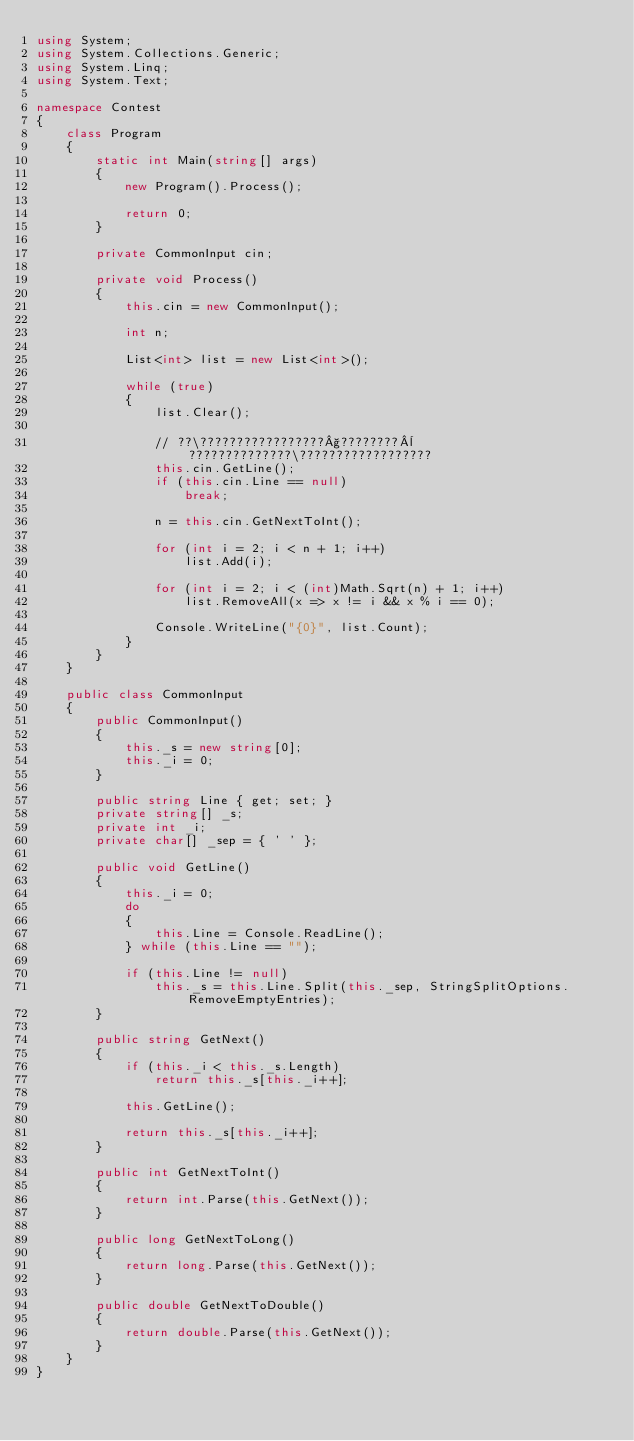Convert code to text. <code><loc_0><loc_0><loc_500><loc_500><_C#_>using System;
using System.Collections.Generic;
using System.Linq;
using System.Text;

namespace Contest
{
    class Program
    {
        static int Main(string[] args)
        {
            new Program().Process();

            return 0;
        }

        private CommonInput cin;

        private void Process()
        {
            this.cin = new CommonInput();

            int n;

            List<int> list = new List<int>();

            while (true)
            {
                list.Clear();

                // ??\?????????????????§????????¨??????????????\??????????????????
                this.cin.GetLine();
                if (this.cin.Line == null)
                    break;

                n = this.cin.GetNextToInt();

                for (int i = 2; i < n + 1; i++)
                    list.Add(i);

                for (int i = 2; i < (int)Math.Sqrt(n) + 1; i++)
                    list.RemoveAll(x => x != i && x % i == 0);

                Console.WriteLine("{0}", list.Count);
            }
        }
    }

    public class CommonInput
    {
        public CommonInput()
        {
            this._s = new string[0];
            this._i = 0;
        }

        public string Line { get; set; }
        private string[] _s;
        private int _i;
        private char[] _sep = { ' ' };

        public void GetLine()
        {
            this._i = 0;
            do
            {
                this.Line = Console.ReadLine();
            } while (this.Line == "");

            if (this.Line != null)
                this._s = this.Line.Split(this._sep, StringSplitOptions.RemoveEmptyEntries);
        }

        public string GetNext()
        {
            if (this._i < this._s.Length)
                return this._s[this._i++];

            this.GetLine();

            return this._s[this._i++];
        }

        public int GetNextToInt()
        {
            return int.Parse(this.GetNext());
        }

        public long GetNextToLong()
        {
            return long.Parse(this.GetNext());
        }

        public double GetNextToDouble()
        {
            return double.Parse(this.GetNext());
        }
    }
}</code> 